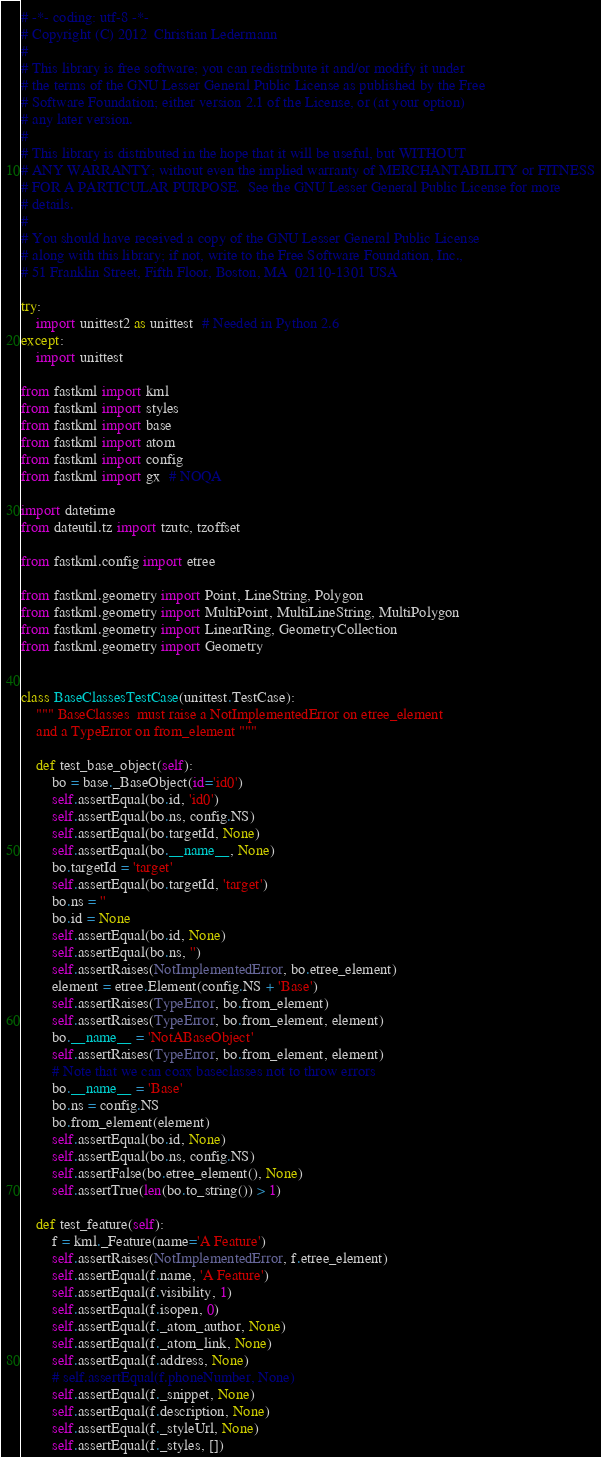Convert code to text. <code><loc_0><loc_0><loc_500><loc_500><_Python_># -*- coding: utf-8 -*-
# Copyright (C) 2012  Christian Ledermann
#
# This library is free software; you can redistribute it and/or modify it under
# the terms of the GNU Lesser General Public License as published by the Free
# Software Foundation; either version 2.1 of the License, or (at your option)
# any later version.
#
# This library is distributed in the hope that it will be useful, but WITHOUT
# ANY WARRANTY; without even the implied warranty of MERCHANTABILITY or FITNESS
# FOR A PARTICULAR PURPOSE.  See the GNU Lesser General Public License for more
# details.
#
# You should have received a copy of the GNU Lesser General Public License
# along with this library; if not, write to the Free Software Foundation, Inc.,
# 51 Franklin Street, Fifth Floor, Boston, MA  02110-1301 USA

try:
    import unittest2 as unittest  # Needed in Python 2.6
except:
    import unittest

from fastkml import kml
from fastkml import styles
from fastkml import base
from fastkml import atom
from fastkml import config
from fastkml import gx  # NOQA

import datetime
from dateutil.tz import tzutc, tzoffset

from fastkml.config import etree

from fastkml.geometry import Point, LineString, Polygon
from fastkml.geometry import MultiPoint, MultiLineString, MultiPolygon
from fastkml.geometry import LinearRing, GeometryCollection
from fastkml.geometry import Geometry


class BaseClassesTestCase(unittest.TestCase):
    """ BaseClasses  must raise a NotImplementedError on etree_element
    and a TypeError on from_element """

    def test_base_object(self):
        bo = base._BaseObject(id='id0')
        self.assertEqual(bo.id, 'id0')
        self.assertEqual(bo.ns, config.NS)
        self.assertEqual(bo.targetId, None)
        self.assertEqual(bo.__name__, None)
        bo.targetId = 'target'
        self.assertEqual(bo.targetId, 'target')
        bo.ns = ''
        bo.id = None
        self.assertEqual(bo.id, None)
        self.assertEqual(bo.ns, '')
        self.assertRaises(NotImplementedError, bo.etree_element)
        element = etree.Element(config.NS + 'Base')
        self.assertRaises(TypeError, bo.from_element)
        self.assertRaises(TypeError, bo.from_element, element)
        bo.__name__ = 'NotABaseObject'
        self.assertRaises(TypeError, bo.from_element, element)
        # Note that we can coax baseclasses not to throw errors
        bo.__name__ = 'Base'
        bo.ns = config.NS
        bo.from_element(element)
        self.assertEqual(bo.id, None)
        self.assertEqual(bo.ns, config.NS)
        self.assertFalse(bo.etree_element(), None)
        self.assertTrue(len(bo.to_string()) > 1)

    def test_feature(self):
        f = kml._Feature(name='A Feature')
        self.assertRaises(NotImplementedError, f.etree_element)
        self.assertEqual(f.name, 'A Feature')
        self.assertEqual(f.visibility, 1)
        self.assertEqual(f.isopen, 0)
        self.assertEqual(f._atom_author, None)
        self.assertEqual(f._atom_link, None)
        self.assertEqual(f.address, None)
        # self.assertEqual(f.phoneNumber, None)
        self.assertEqual(f._snippet, None)
        self.assertEqual(f.description, None)
        self.assertEqual(f._styleUrl, None)
        self.assertEqual(f._styles, [])</code> 